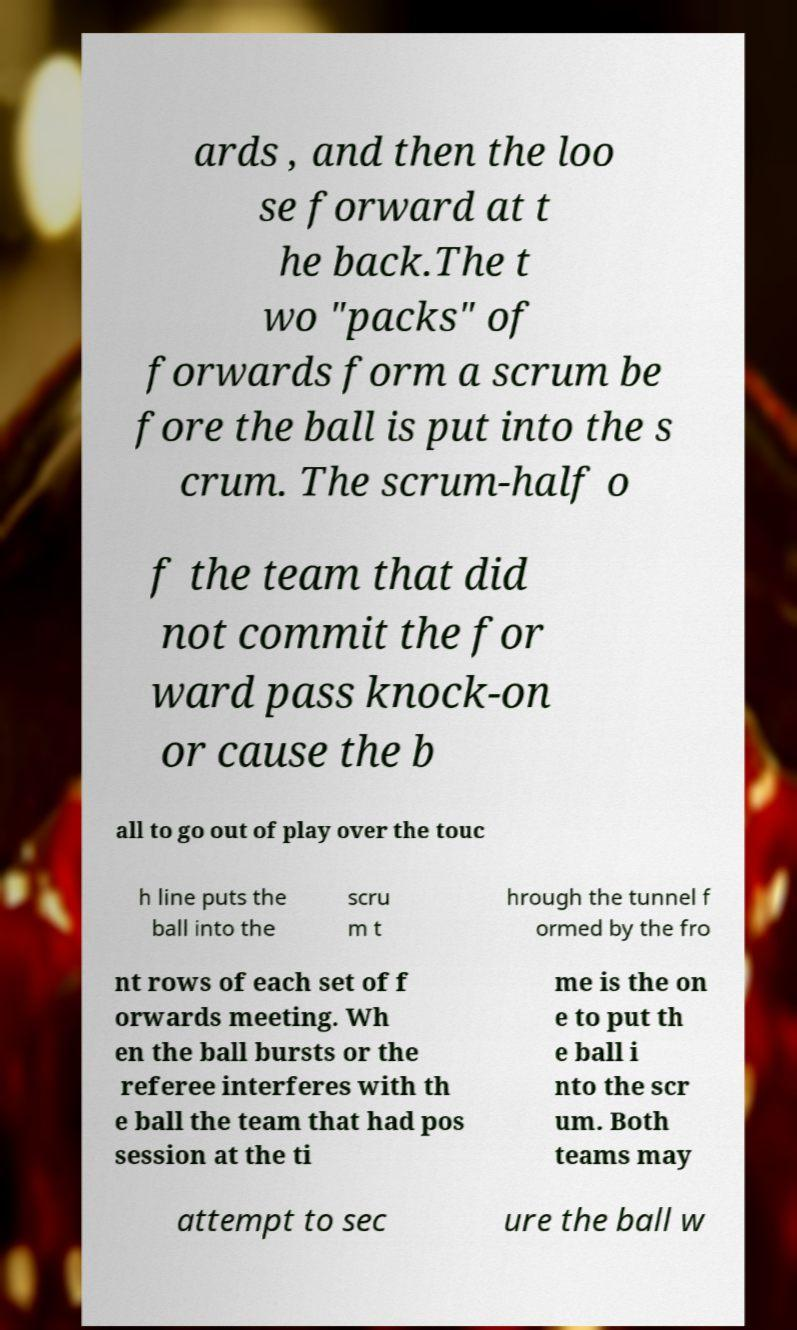I need the written content from this picture converted into text. Can you do that? ards , and then the loo se forward at t he back.The t wo "packs" of forwards form a scrum be fore the ball is put into the s crum. The scrum-half o f the team that did not commit the for ward pass knock-on or cause the b all to go out of play over the touc h line puts the ball into the scru m t hrough the tunnel f ormed by the fro nt rows of each set of f orwards meeting. Wh en the ball bursts or the referee interferes with th e ball the team that had pos session at the ti me is the on e to put th e ball i nto the scr um. Both teams may attempt to sec ure the ball w 